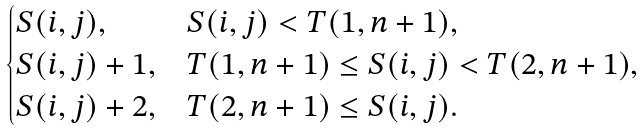<formula> <loc_0><loc_0><loc_500><loc_500>\begin{cases} S ( i , j ) , & S ( i , j ) < T ( 1 , n + 1 ) , \\ S ( i , j ) + 1 , & T ( 1 , n + 1 ) \leq S ( i , j ) < T ( 2 , n + 1 ) , \\ S ( i , j ) + 2 , & T ( 2 , n + 1 ) \leq S ( i , j ) . \end{cases}</formula> 